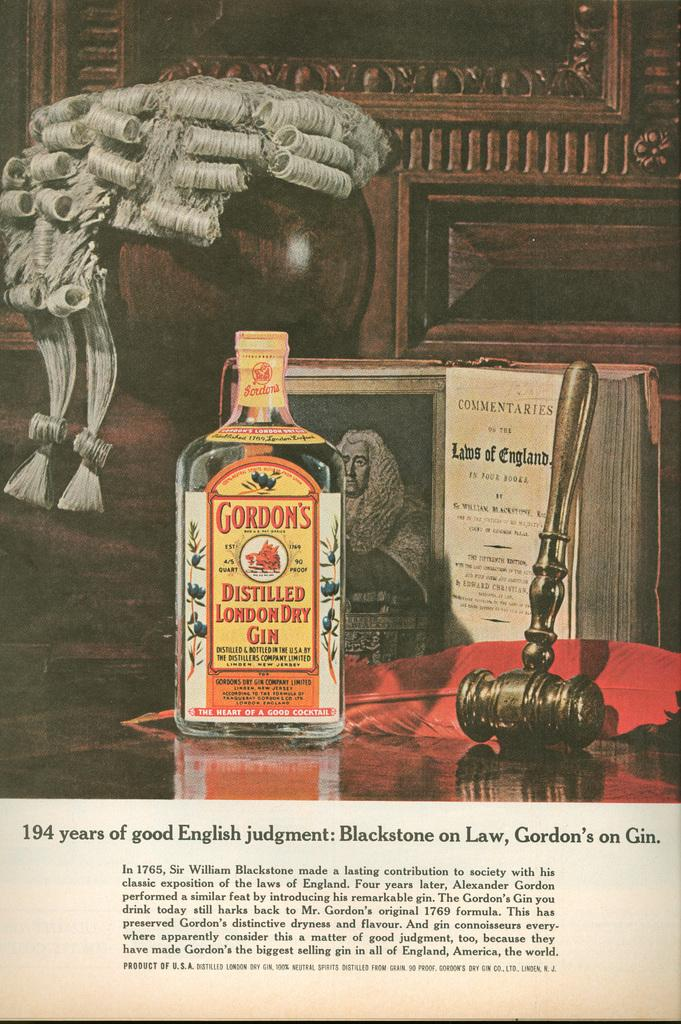<image>
Describe the image concisely. An magazine advertisment for Gordon's Distilled London Dry Gin. 